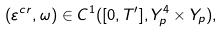Convert formula to latex. <formula><loc_0><loc_0><loc_500><loc_500>( \varepsilon ^ { c r } , \omega ) \in C ^ { 1 } ( [ 0 , T ^ { \prime } ] , Y ^ { 4 } _ { p } \times Y _ { p } ) ,</formula> 